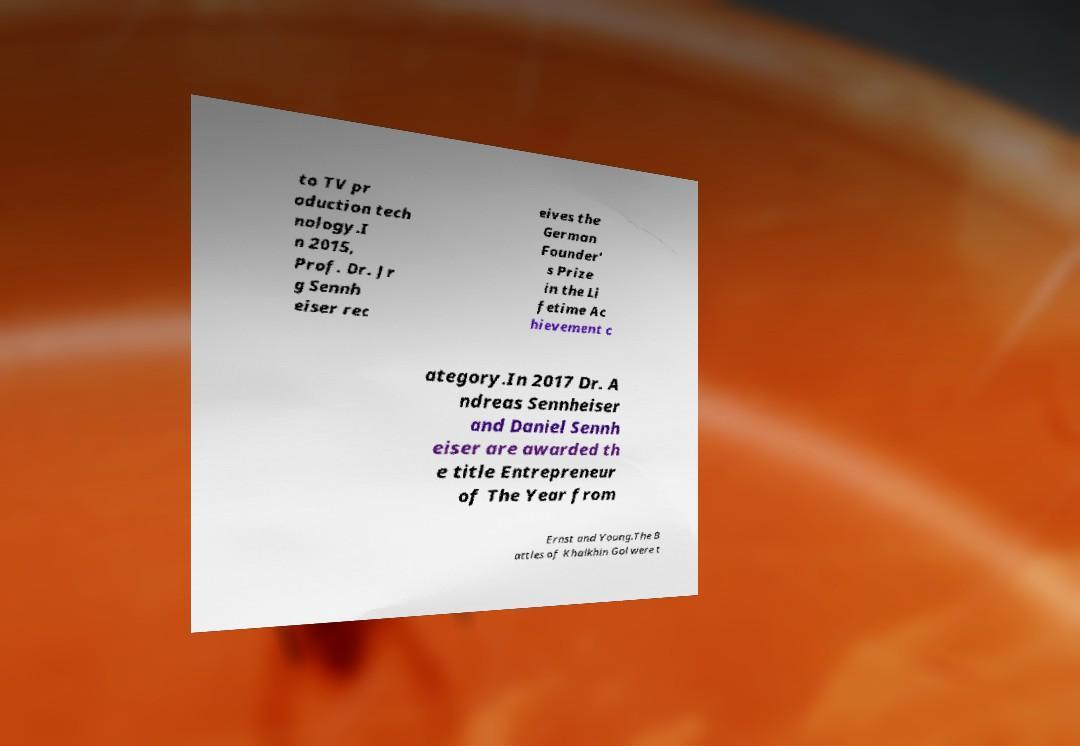Please identify and transcribe the text found in this image. to TV pr oduction tech nology.I n 2015, Prof. Dr. Jr g Sennh eiser rec eives the German Founder' s Prize in the Li fetime Ac hievement c ategory.In 2017 Dr. A ndreas Sennheiser and Daniel Sennh eiser are awarded th e title Entrepreneur of The Year from Ernst and Young.The B attles of Khalkhin Gol were t 